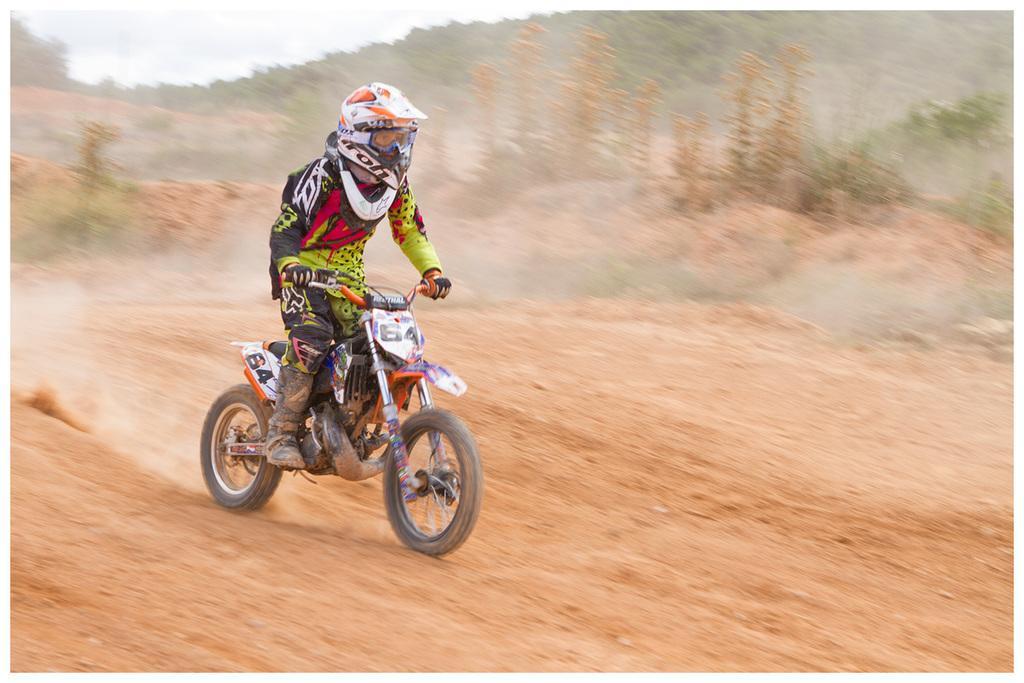Can you describe this image briefly? Here I can see a person wearing jacket, helmet on the head and riding the bike on the ground. In the background there are some plants and a hill. 